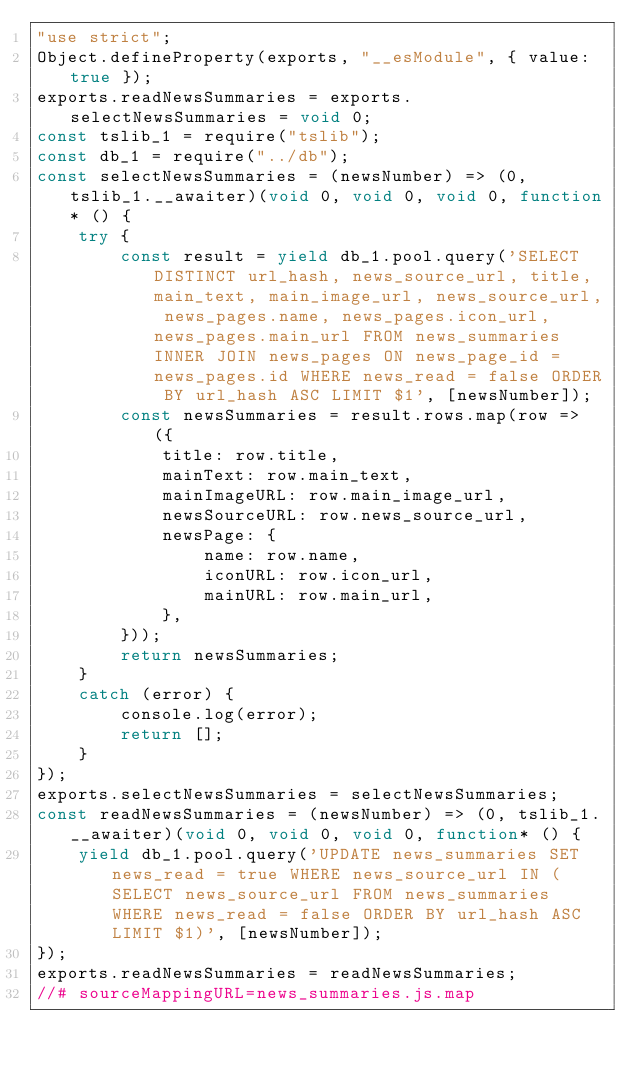<code> <loc_0><loc_0><loc_500><loc_500><_JavaScript_>"use strict";
Object.defineProperty(exports, "__esModule", { value: true });
exports.readNewsSummaries = exports.selectNewsSummaries = void 0;
const tslib_1 = require("tslib");
const db_1 = require("../db");
const selectNewsSummaries = (newsNumber) => (0, tslib_1.__awaiter)(void 0, void 0, void 0, function* () {
    try {
        const result = yield db_1.pool.query('SELECT DISTINCT url_hash, news_source_url, title, main_text, main_image_url, news_source_url, news_pages.name, news_pages.icon_url, news_pages.main_url FROM news_summaries INNER JOIN news_pages ON news_page_id = news_pages.id WHERE news_read = false ORDER BY url_hash ASC LIMIT $1', [newsNumber]);
        const newsSummaries = result.rows.map(row => ({
            title: row.title,
            mainText: row.main_text,
            mainImageURL: row.main_image_url,
            newsSourceURL: row.news_source_url,
            newsPage: {
                name: row.name,
                iconURL: row.icon_url,
                mainURL: row.main_url,
            },
        }));
        return newsSummaries;
    }
    catch (error) {
        console.log(error);
        return [];
    }
});
exports.selectNewsSummaries = selectNewsSummaries;
const readNewsSummaries = (newsNumber) => (0, tslib_1.__awaiter)(void 0, void 0, void 0, function* () {
    yield db_1.pool.query('UPDATE news_summaries SET news_read = true WHERE news_source_url IN (SELECT news_source_url FROM news_summaries WHERE news_read = false ORDER BY url_hash ASC LIMIT $1)', [newsNumber]);
});
exports.readNewsSummaries = readNewsSummaries;
//# sourceMappingURL=news_summaries.js.map</code> 